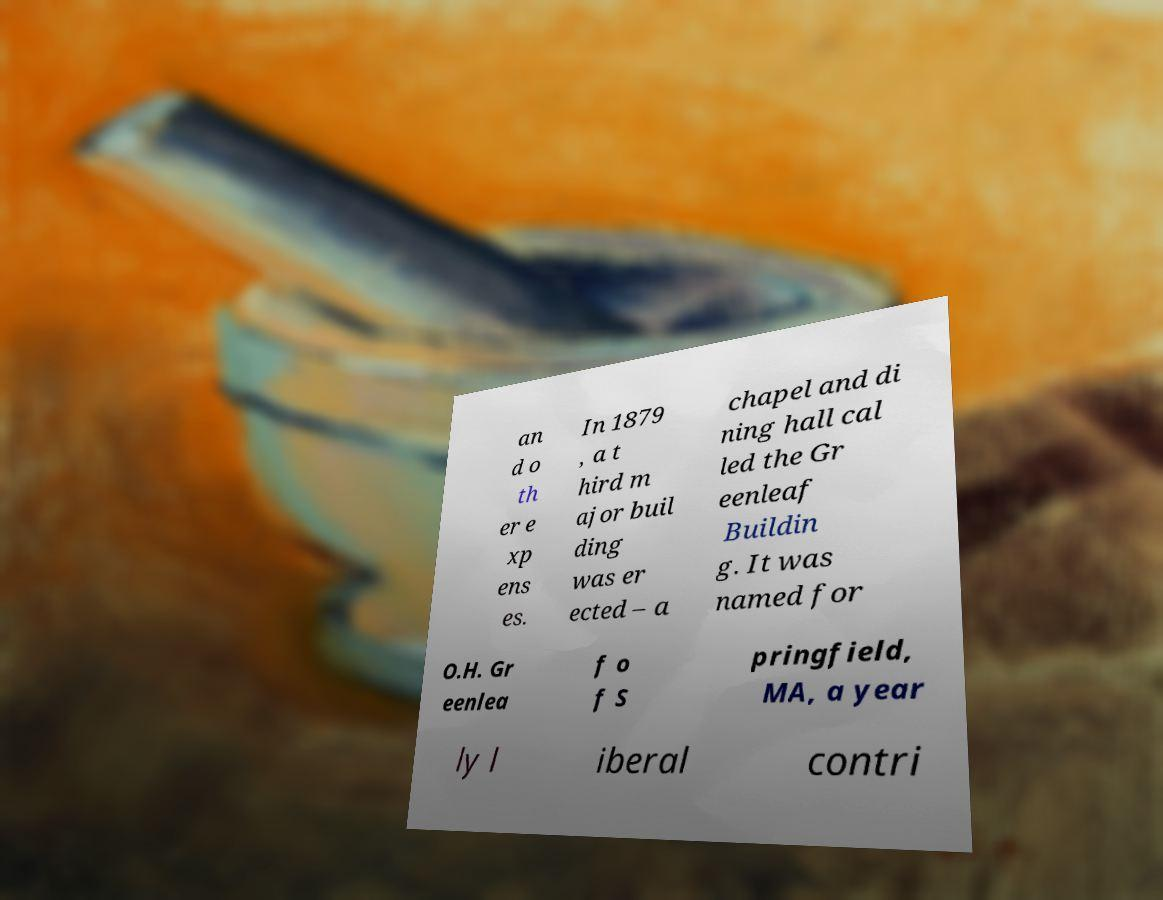Could you assist in decoding the text presented in this image and type it out clearly? an d o th er e xp ens es. In 1879 , a t hird m ajor buil ding was er ected – a chapel and di ning hall cal led the Gr eenleaf Buildin g. It was named for O.H. Gr eenlea f o f S pringfield, MA, a year ly l iberal contri 